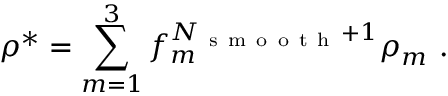<formula> <loc_0><loc_0><loc_500><loc_500>\rho ^ { * } = \sum _ { m = 1 } ^ { 3 } f _ { m } ^ { N _ { s m o o t h } + 1 } \rho _ { m } .</formula> 